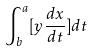<formula> <loc_0><loc_0><loc_500><loc_500>\int _ { b } ^ { a } [ y \frac { d x } { d t } ] d t</formula> 